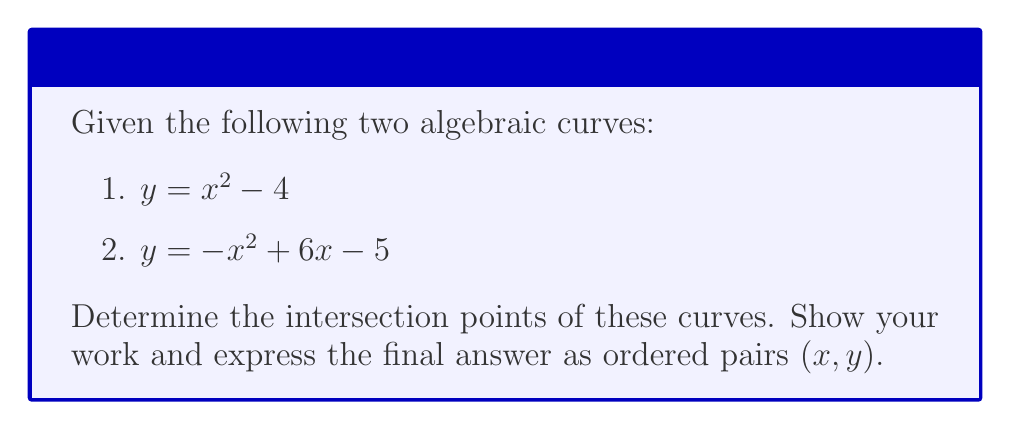Provide a solution to this math problem. To find the intersection points, we need to solve the system of equations:

$$\begin{cases}
y = x^2 - 4 \\
y = -x^2 + 6x - 5
\end{cases}$$

Step 1: Set the equations equal to each other
$x^2 - 4 = -x^2 + 6x - 5$

Step 2: Rearrange the equation
$2x^2 - 6x + 1 = 0$

Step 3: Simplify by dividing all terms by 2
$x^2 - 3x + \frac{1}{2} = 0$

Step 4: Use the quadratic formula to solve for x
$x = \frac{-b \pm \sqrt{b^2 - 4ac}}{2a}$

Where $a=1$, $b=-3$, and $c=\frac{1}{2}$

$x = \frac{3 \pm \sqrt{9 - 2}}{2} = \frac{3 \pm \sqrt{7}}{2}$

Step 5: Calculate the two x-values
$x_1 = \frac{3 + \sqrt{7}}{2} \approx 2.82$
$x_2 = \frac{3 - \sqrt{7}}{2} \approx 0.18$

Step 6: Find the corresponding y-values by substituting x into either original equation
For $x_1$: $y_1 = (\frac{3 + \sqrt{7}}{2})^2 - 4 \approx 3.97$
For $x_2$: $y_2 = (\frac{3 - \sqrt{7}}{2})^2 - 4 \approx -3.97$

Therefore, the intersection points are approximately $(2.82, 3.97)$ and $(0.18, -3.97)$.
Answer: $(\frac{3 + \sqrt{7}}{2}, \frac{7 + 3\sqrt{7}}{2})$ and $(\frac{3 - \sqrt{7}}{2}, \frac{7 - 3\sqrt{7}}{2})$ 